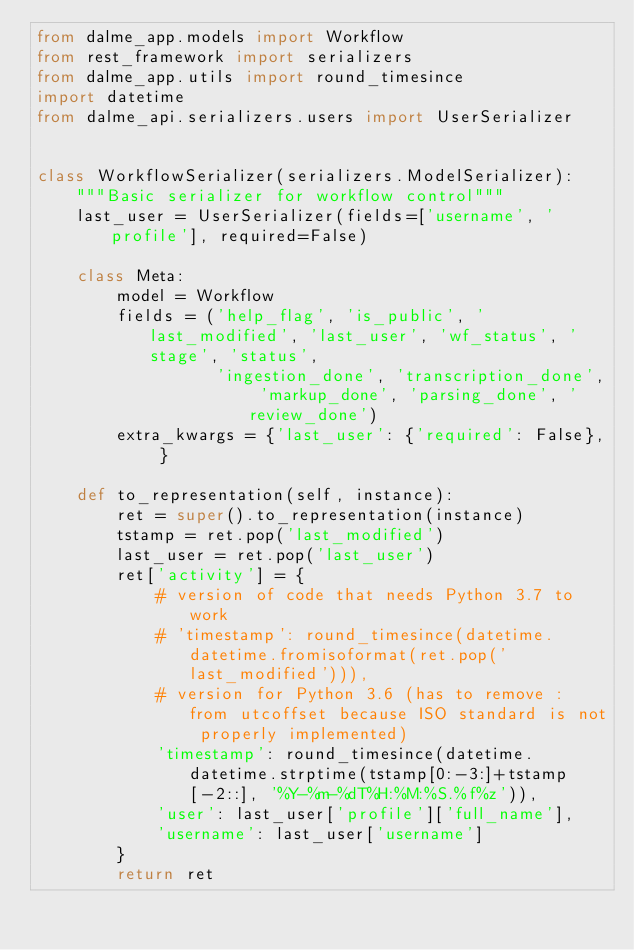<code> <loc_0><loc_0><loc_500><loc_500><_Python_>from dalme_app.models import Workflow
from rest_framework import serializers
from dalme_app.utils import round_timesince
import datetime
from dalme_api.serializers.users import UserSerializer


class WorkflowSerializer(serializers.ModelSerializer):
    """Basic serializer for workflow control"""
    last_user = UserSerializer(fields=['username', 'profile'], required=False)

    class Meta:
        model = Workflow
        fields = ('help_flag', 'is_public', 'last_modified', 'last_user', 'wf_status', 'stage', 'status',
                  'ingestion_done', 'transcription_done', 'markup_done', 'parsing_done', 'review_done')
        extra_kwargs = {'last_user': {'required': False}, }

    def to_representation(self, instance):
        ret = super().to_representation(instance)
        tstamp = ret.pop('last_modified')
        last_user = ret.pop('last_user')
        ret['activity'] = {
            # version of code that needs Python 3.7 to work
            # 'timestamp': round_timesince(datetime.datetime.fromisoformat(ret.pop('last_modified'))),
            # version for Python 3.6 (has to remove : from utcoffset because ISO standard is not properly implemented)
            'timestamp': round_timesince(datetime.datetime.strptime(tstamp[0:-3:]+tstamp[-2::], '%Y-%m-%dT%H:%M:%S.%f%z')),
            'user': last_user['profile']['full_name'],
            'username': last_user['username']
        }
        return ret
</code> 